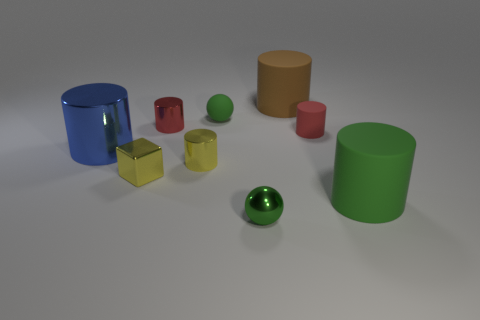Subtract all blue cylinders. How many cylinders are left? 5 Subtract all small shiny cylinders. How many cylinders are left? 4 Subtract all brown cylinders. Subtract all red balls. How many cylinders are left? 5 Add 1 gray cylinders. How many objects exist? 10 Subtract all cubes. How many objects are left? 8 Subtract 0 purple spheres. How many objects are left? 9 Subtract all large gray things. Subtract all tiny yellow metallic cubes. How many objects are left? 8 Add 9 big green things. How many big green things are left? 10 Add 9 large purple rubber spheres. How many large purple rubber spheres exist? 9 